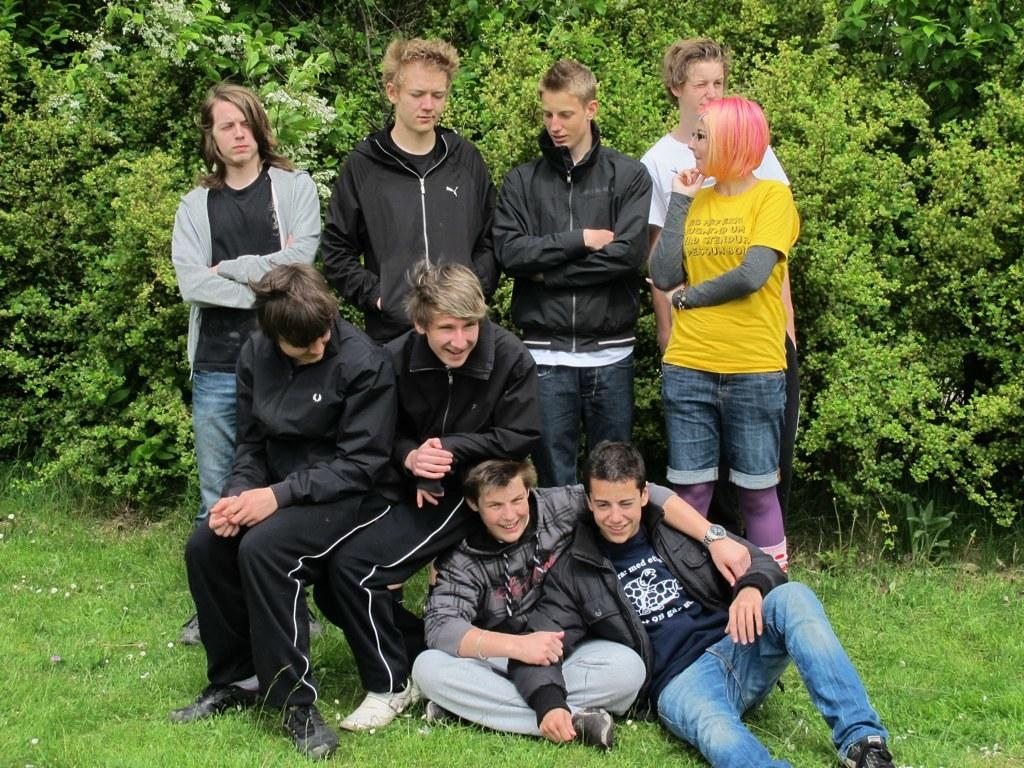How many people are in the image? There are many people in the image. What are some of the people doing in the image? Some people are standing, and some people are sitting. What is the ground made of in the image? The ground is covered with grass. What can be seen in the background of the image? There are trees in the background. What type of jewel is being passed between the brothers in the image? There are no brothers or jewels present in the image. 